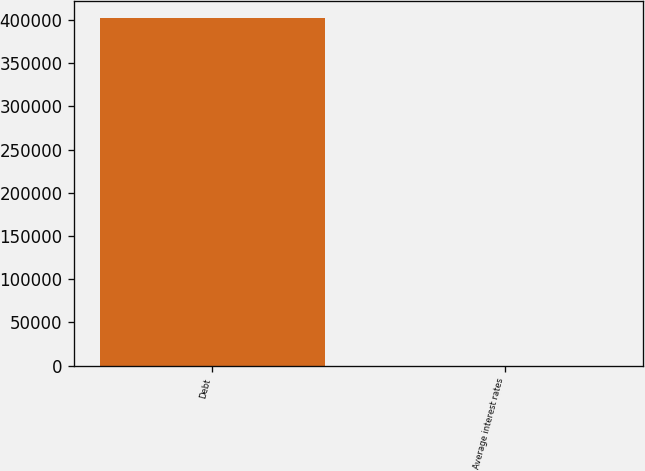Convert chart to OTSL. <chart><loc_0><loc_0><loc_500><loc_500><bar_chart><fcel>Debt<fcel>Average interest rates<nl><fcel>401970<fcel>5.5<nl></chart> 